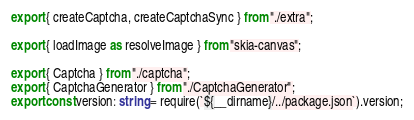<code> <loc_0><loc_0><loc_500><loc_500><_TypeScript_>export { createCaptcha, createCaptchaSync } from "./extra";

export { loadImage as resolveImage } from "skia-canvas";

export { Captcha } from "./captcha";
export { CaptchaGenerator } from "./CaptchaGenerator";
export const version: string = require(`${__dirname}/../package.json`).version;
</code> 